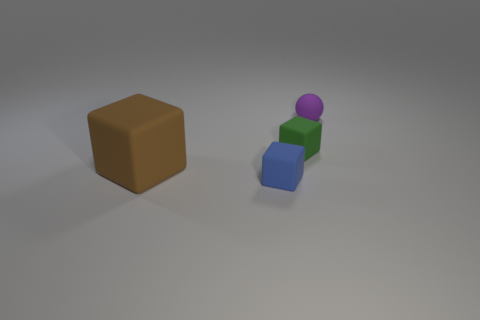Is there any other thing of the same color as the big rubber object?
Give a very brief answer. No. Do the tiny ball and the tiny rubber cube to the right of the small blue thing have the same color?
Provide a short and direct response. No. Is the number of large blue balls greater than the number of big objects?
Make the answer very short. No. There is a small matte cube that is in front of the big brown cube; is its color the same as the tiny sphere?
Ensure brevity in your answer.  No. What is the color of the large thing?
Make the answer very short. Brown. Are there any blue blocks on the left side of the matte cube that is in front of the big brown rubber cube?
Ensure brevity in your answer.  No. What shape is the object that is to the left of the tiny matte block that is on the left side of the green thing?
Offer a terse response. Cube. Is the number of tiny blue cylinders less than the number of large matte blocks?
Your answer should be very brief. Yes. Does the small purple ball have the same material as the green object?
Provide a short and direct response. Yes. The small object that is on the left side of the rubber ball and behind the large brown matte cube is what color?
Keep it short and to the point. Green. 